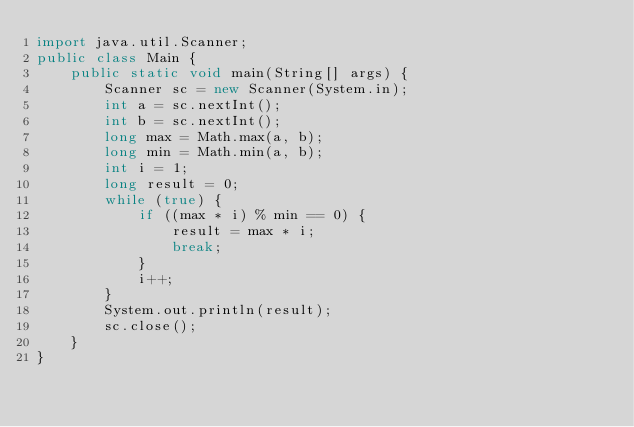<code> <loc_0><loc_0><loc_500><loc_500><_Java_>import java.util.Scanner;
public class Main {
    public static void main(String[] args) {
        Scanner sc = new Scanner(System.in);
        int a = sc.nextInt();
        int b = sc.nextInt();
        long max = Math.max(a, b);
        long min = Math.min(a, b);
        int i = 1;
        long result = 0;
        while (true) {
            if ((max * i) % min == 0) {
                result = max * i;
                break;
            }
            i++;
        }
        System.out.println(result);
        sc.close();
    }
}</code> 